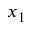Convert formula to latex. <formula><loc_0><loc_0><loc_500><loc_500>x _ { 1 }</formula> 